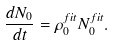<formula> <loc_0><loc_0><loc_500><loc_500>\frac { d N _ { 0 } } { d t } = \rho _ { 0 } ^ { f i t } N _ { 0 } ^ { f i t } .</formula> 